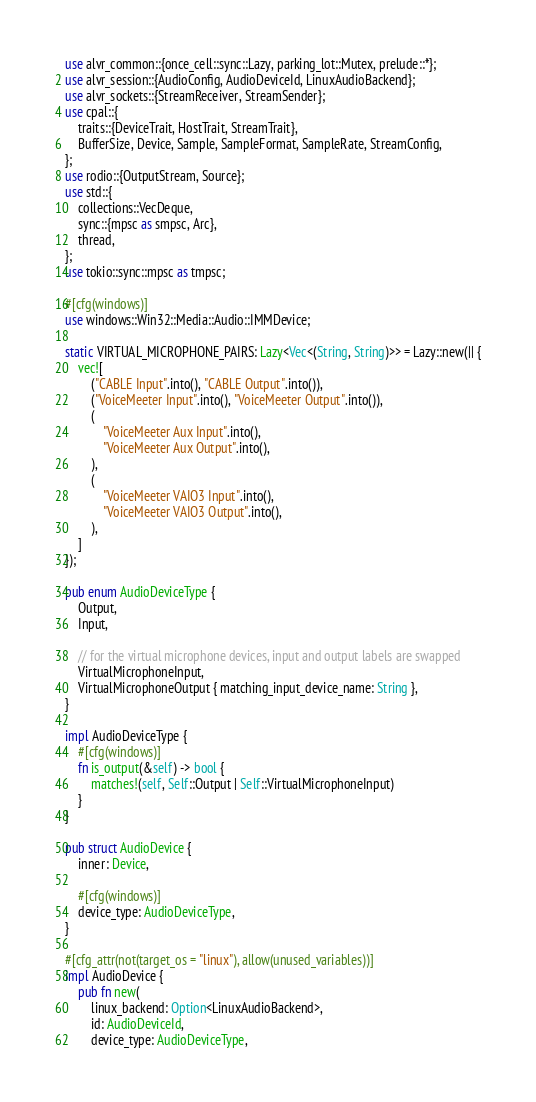<code> <loc_0><loc_0><loc_500><loc_500><_Rust_>use alvr_common::{once_cell::sync::Lazy, parking_lot::Mutex, prelude::*};
use alvr_session::{AudioConfig, AudioDeviceId, LinuxAudioBackend};
use alvr_sockets::{StreamReceiver, StreamSender};
use cpal::{
    traits::{DeviceTrait, HostTrait, StreamTrait},
    BufferSize, Device, Sample, SampleFormat, SampleRate, StreamConfig,
};
use rodio::{OutputStream, Source};
use std::{
    collections::VecDeque,
    sync::{mpsc as smpsc, Arc},
    thread,
};
use tokio::sync::mpsc as tmpsc;

#[cfg(windows)]
use windows::Win32::Media::Audio::IMMDevice;

static VIRTUAL_MICROPHONE_PAIRS: Lazy<Vec<(String, String)>> = Lazy::new(|| {
    vec![
        ("CABLE Input".into(), "CABLE Output".into()),
        ("VoiceMeeter Input".into(), "VoiceMeeter Output".into()),
        (
            "VoiceMeeter Aux Input".into(),
            "VoiceMeeter Aux Output".into(),
        ),
        (
            "VoiceMeeter VAIO3 Input".into(),
            "VoiceMeeter VAIO3 Output".into(),
        ),
    ]
});

pub enum AudioDeviceType {
    Output,
    Input,

    // for the virtual microphone devices, input and output labels are swapped
    VirtualMicrophoneInput,
    VirtualMicrophoneOutput { matching_input_device_name: String },
}

impl AudioDeviceType {
    #[cfg(windows)]
    fn is_output(&self) -> bool {
        matches!(self, Self::Output | Self::VirtualMicrophoneInput)
    }
}

pub struct AudioDevice {
    inner: Device,

    #[cfg(windows)]
    device_type: AudioDeviceType,
}

#[cfg_attr(not(target_os = "linux"), allow(unused_variables))]
impl AudioDevice {
    pub fn new(
        linux_backend: Option<LinuxAudioBackend>,
        id: AudioDeviceId,
        device_type: AudioDeviceType,</code> 